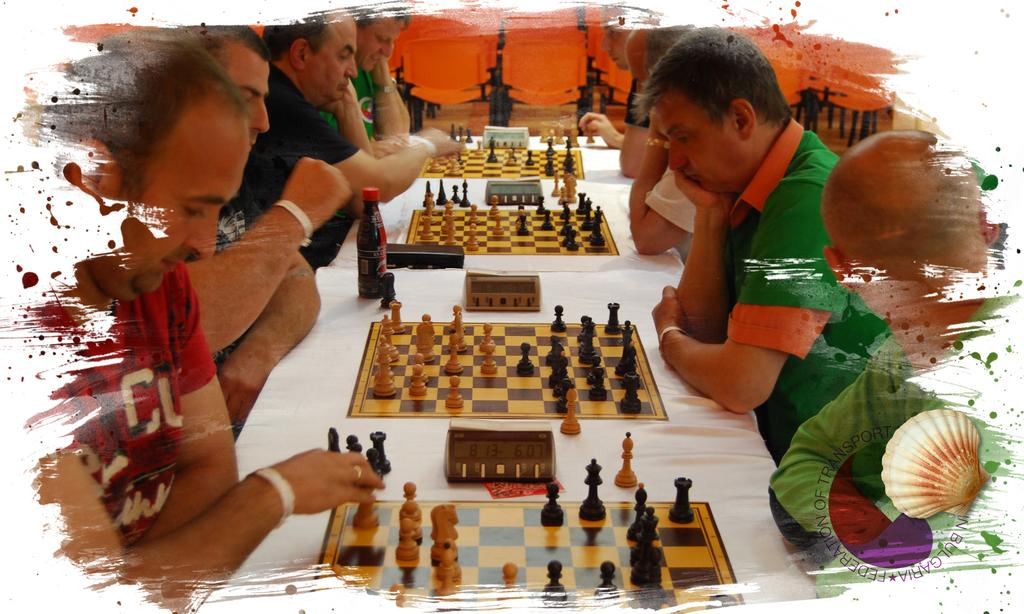What is happening in the image involving a group of people? There is a group of people in the image, and they are seated. What activity are the people engaged in? The people are playing chess, as there are chess boards in front of them. What can be seen on the table in the image? There is a bottle on the table. How many spoons are visible in the image? There is no spoon present in the image. 